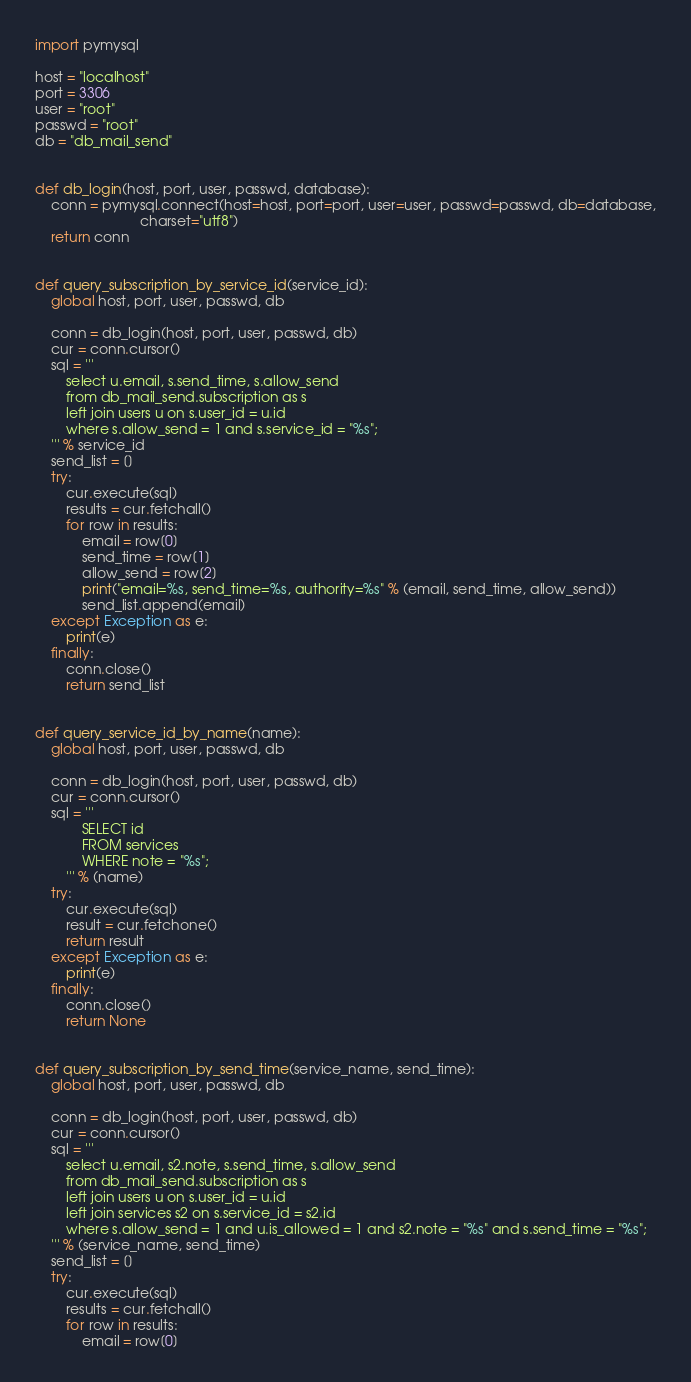<code> <loc_0><loc_0><loc_500><loc_500><_Python_>import pymysql

host = "localhost"
port = 3306
user = "root"
passwd = "root"
db = "db_mail_send"


def db_login(host, port, user, passwd, database):
    conn = pymysql.connect(host=host, port=port, user=user, passwd=passwd, db=database,
                           charset="utf8")
    return conn


def query_subscription_by_service_id(service_id):
    global host, port, user, passwd, db

    conn = db_login(host, port, user, passwd, db)
    cur = conn.cursor()
    sql = '''
        select u.email, s.send_time, s.allow_send
        from db_mail_send.subscription as s
        left join users u on s.user_id = u.id
        where s.allow_send = 1 and s.service_id = "%s";
    ''' % service_id
    send_list = []
    try:
        cur.execute(sql)
        results = cur.fetchall()
        for row in results:
            email = row[0]
            send_time = row[1]
            allow_send = row[2]
            print("email=%s, send_time=%s, authority=%s" % (email, send_time, allow_send))
            send_list.append(email)
    except Exception as e:
        print(e)
    finally:
        conn.close()
        return send_list


def query_service_id_by_name(name):
    global host, port, user, passwd, db

    conn = db_login(host, port, user, passwd, db)
    cur = conn.cursor()
    sql = '''
            SELECT id
            FROM services
            WHERE note = "%s";
        ''' % (name)
    try:
        cur.execute(sql)
        result = cur.fetchone()
        return result
    except Exception as e:
        print(e)
    finally:
        conn.close()
        return None


def query_subscription_by_send_time(service_name, send_time):
    global host, port, user, passwd, db

    conn = db_login(host, port, user, passwd, db)
    cur = conn.cursor()
    sql = '''
        select u.email, s2.note, s.send_time, s.allow_send
        from db_mail_send.subscription as s
        left join users u on s.user_id = u.id
        left join services s2 on s.service_id = s2.id
        where s.allow_send = 1 and u.is_allowed = 1 and s2.note = "%s" and s.send_time = "%s"; 
    ''' % (service_name, send_time)
    send_list = []
    try:
        cur.execute(sql)
        results = cur.fetchall()
        for row in results:
            email = row[0]</code> 